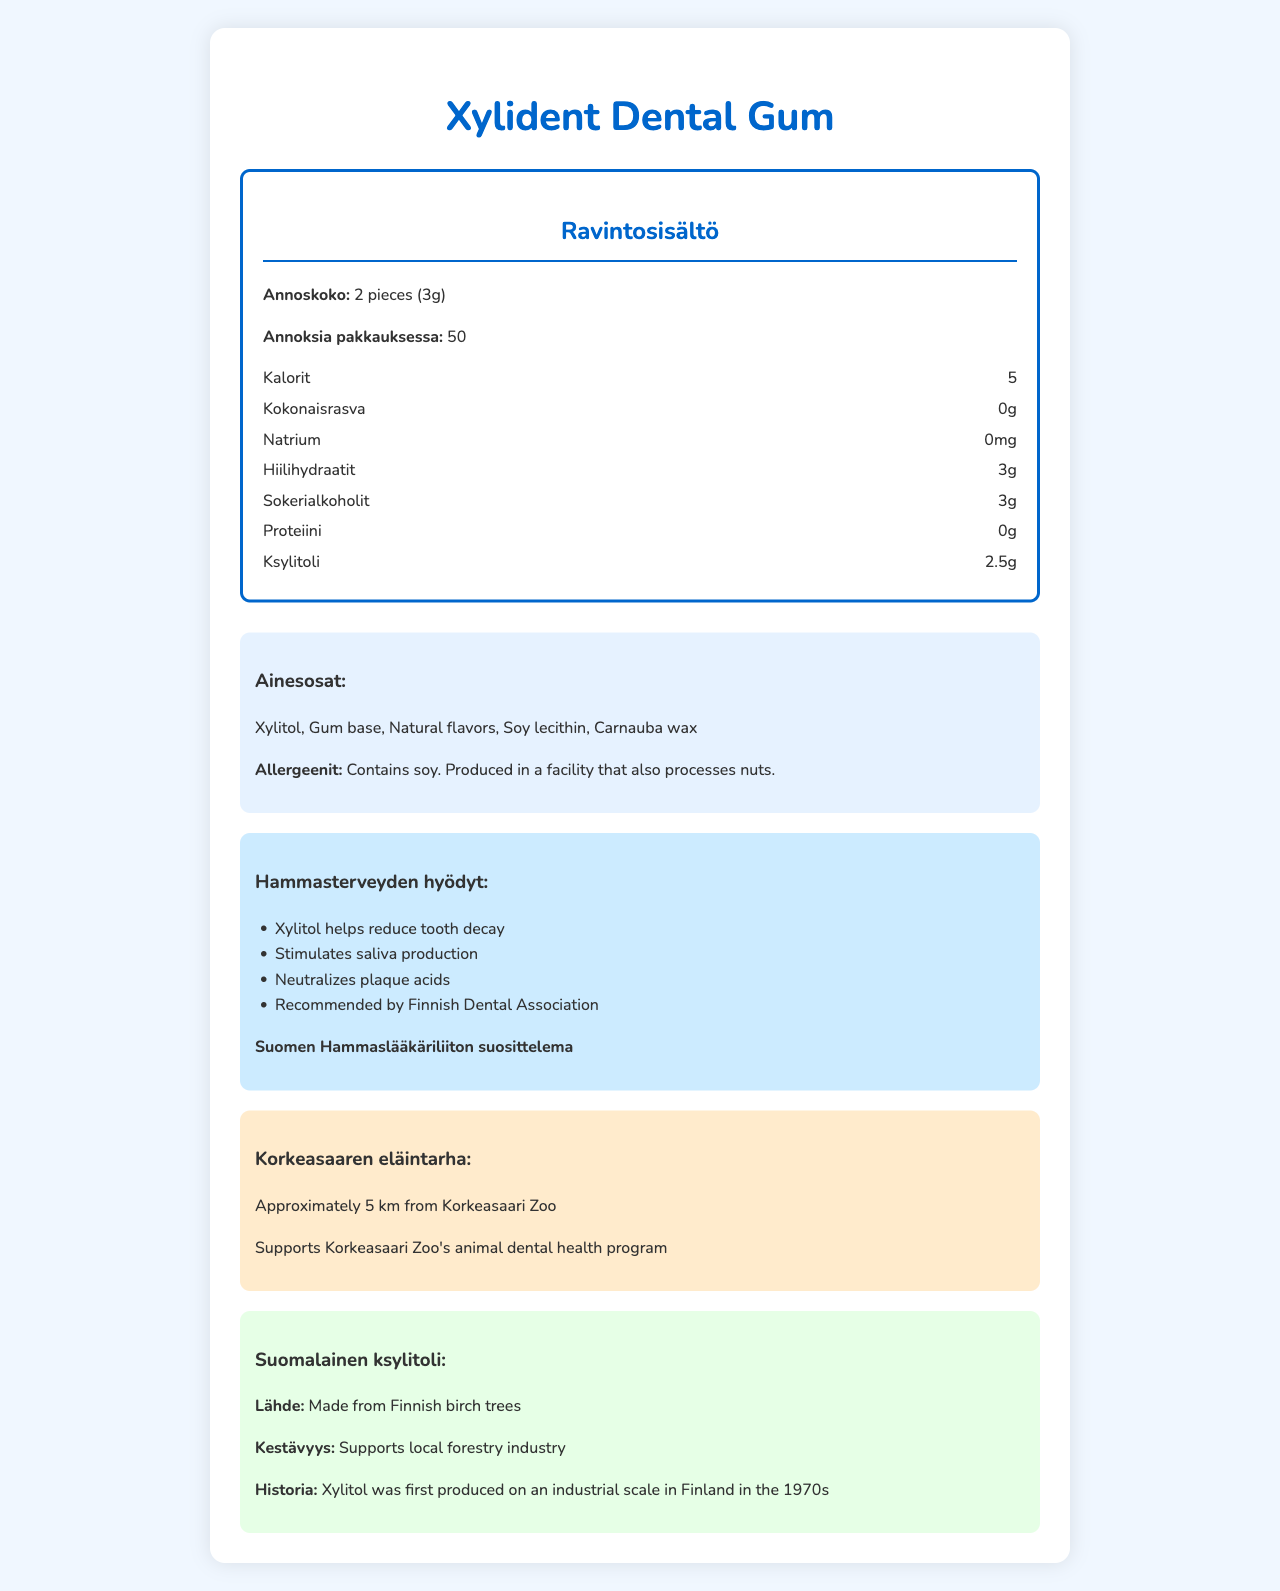what is the serving size for Xylident Dental Gum? The document states that the serving size is 2 pieces (3g).
Answer: 2 pieces (3g) who is the manufacturer of Xylident Dental Gum? The document notes that Fazer Makeiset Oy is the manufacturer of the gum.
Answer: Fazer Makeiset Oy how many calories are there per serving of Xylident Dental Gum? The document specifies that there are 5 calories per serving.
Answer: 5 what are the ingredients listed for Xylident Dental Gum? The ingredients section in the document lists these specific ingredients.
Answer: Xylitol, Gum base, Natural flavors, Soy lecithin, Carnauba wax what allergen information is provided for Xylident Dental Gum? The allergen information section specifies this about the product.
Answer: Contains soy. Produced in a facility that also processes nuts. which association recommends Xylident Dental Gum for dental health? The document states that the gum is recommended by the Finnish Dental Association.
Answer: Finnish Dental Association what is the primary benefit of xylitol in Xylident Dental Gum? The document lists this as one of the dental benefits of xylitol.
Answer: Helps reduce tooth decay where is Xylident Dental Gum made? The document mentions that the gum is made in Finland.
Answer: Finland how far is Fazerintie 6, 01230 Vantaa from Korkeasaari Zoo? The document indicates the distance from the Korkeasaari Zoo as approximately 5 km.
Answer: Approximately 5 km does Xylident Dental Gum contain any sugars? According to the document, the gum contains zero total sugars.
Answer: No which organization’s seal does Xylident Dental Gum have? The document confirms that the gum has the Finnish Dental Association seal.
Answer: Finnish Dental Association what should be done to store the gum properly? The document provides this as part of the storage instructions.
Answer: Store in a cool, dry place what sustainability practice is associated with Xylident Dental Gum's xylitol? A. Supports global forestry industry B. Supports local forestry industry C. Is not sustainable D. Only uses imported birch trees The document states that the xylitol supports the local forestry industry.
Answer: B what dental benefit does Xylident Dental Gum offer? A. Strengthens enamel B. Provides whitening C. Helps reduce tooth decay D. Adds extra calcium The dental benefits section lists "Helps reduce tooth decay" as one of the benefits.
Answer: C is the packaging of Xylident Dental Gum recyclable? The document mentions that the packaging is recyclable.
Answer: Yes does Xylident Dental Gum contain any dietary fiber? According to the nutritional facts, the gum contains 0g of dietary fiber.
Answer: No what is the main idea of the document? The document showcases all relevant facts and benefits of Xylident Dental Gum, including nutritional content, ingredients, dental recommendations, and origin, giving a comprehensive overview of the product.
Answer: The document provides detailed nutritional information about Xylident Dental Gum, including its ingredients, dental benefits, and origin. It highlights the product’s low-calorie content, its xylitol content, and its dental health benefits, and shows its sustainability and local production. what is the best-before date of the Xylident Dental Gum container? The document mentions that the best-before date is printed on the package, but does not provide a specific date.
Answer: Not enough information 